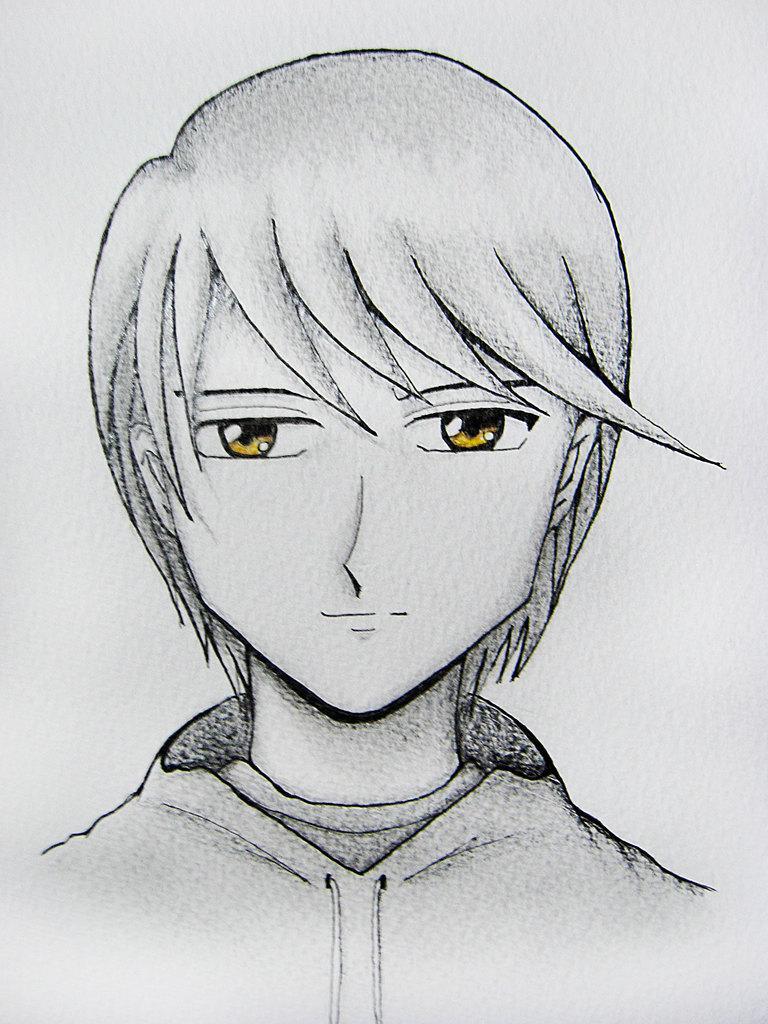In one or two sentences, can you explain what this image depicts? In this image there is a sketch of a person. 